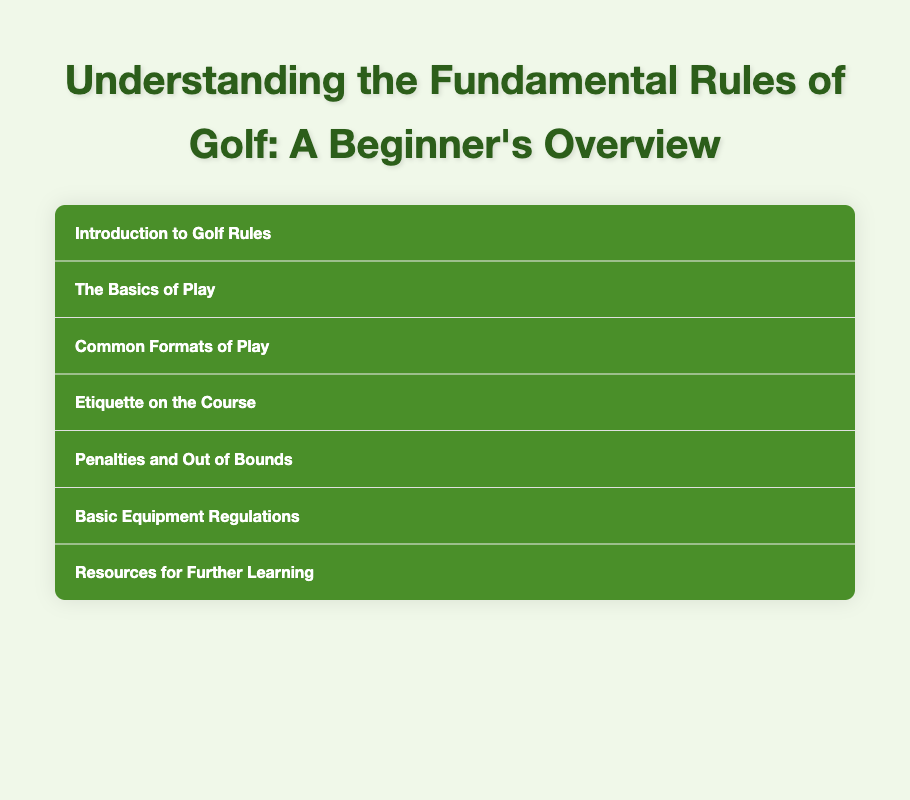What is the title of the document? The title of the document is specified in the HTML that describes its content.
Answer: Understanding the Fundamental Rules of Golf: A Beginner's Overview What section explains common penalties? The document is organized into sections, and the one covering penalties is directly named.
Answer: Penalties and Out of Bounds How many menu items are there in the document? The number of menu items can be counted by checking the structure of the document.
Answer: Seven What is the primary focus of the "Etiquette on the Course" section? This section covers fundamental practices expected from golfers during play and procedures to maintain the course.
Answer: Maintaining pace of play Which format of play is mentioned after "The Basics of Play"? The sections are organized to follow specific formats of play, one of which is named directly after the basics.
Answer: Common Formats of Play What does the "Basic Equipment Regulations" section introduce? The section presents an overview regarding the standards that golf equipment must meet.
Answer: Equipment regulations What resource is suggested for further learning? The document advises specific resources for beginners who want to learn more about golf rules.
Answer: USGA website 